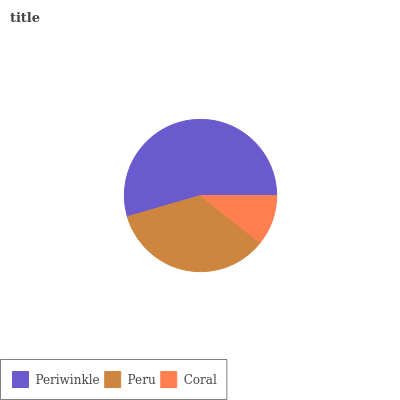Is Coral the minimum?
Answer yes or no. Yes. Is Periwinkle the maximum?
Answer yes or no. Yes. Is Peru the minimum?
Answer yes or no. No. Is Peru the maximum?
Answer yes or no. No. Is Periwinkle greater than Peru?
Answer yes or no. Yes. Is Peru less than Periwinkle?
Answer yes or no. Yes. Is Peru greater than Periwinkle?
Answer yes or no. No. Is Periwinkle less than Peru?
Answer yes or no. No. Is Peru the high median?
Answer yes or no. Yes. Is Peru the low median?
Answer yes or no. Yes. Is Periwinkle the high median?
Answer yes or no. No. Is Coral the low median?
Answer yes or no. No. 